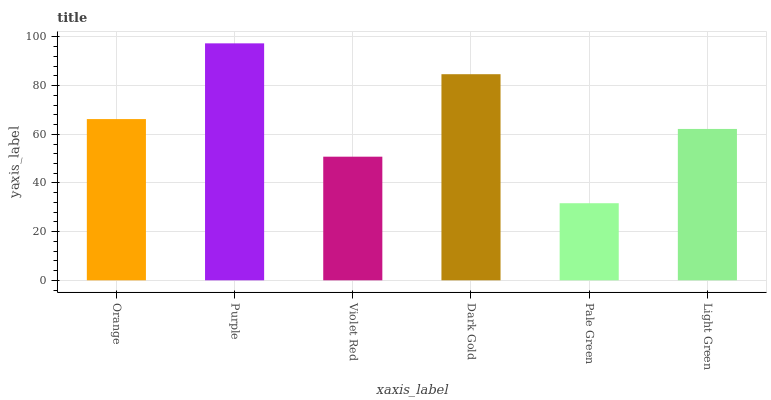Is Pale Green the minimum?
Answer yes or no. Yes. Is Purple the maximum?
Answer yes or no. Yes. Is Violet Red the minimum?
Answer yes or no. No. Is Violet Red the maximum?
Answer yes or no. No. Is Purple greater than Violet Red?
Answer yes or no. Yes. Is Violet Red less than Purple?
Answer yes or no. Yes. Is Violet Red greater than Purple?
Answer yes or no. No. Is Purple less than Violet Red?
Answer yes or no. No. Is Orange the high median?
Answer yes or no. Yes. Is Light Green the low median?
Answer yes or no. Yes. Is Violet Red the high median?
Answer yes or no. No. Is Violet Red the low median?
Answer yes or no. No. 